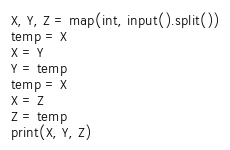<code> <loc_0><loc_0><loc_500><loc_500><_Python_>X, Y, Z = map(int, input().split())
temp = X
X = Y
Y = temp
temp = X
X = Z
Z = temp
print(X, Y, Z)</code> 